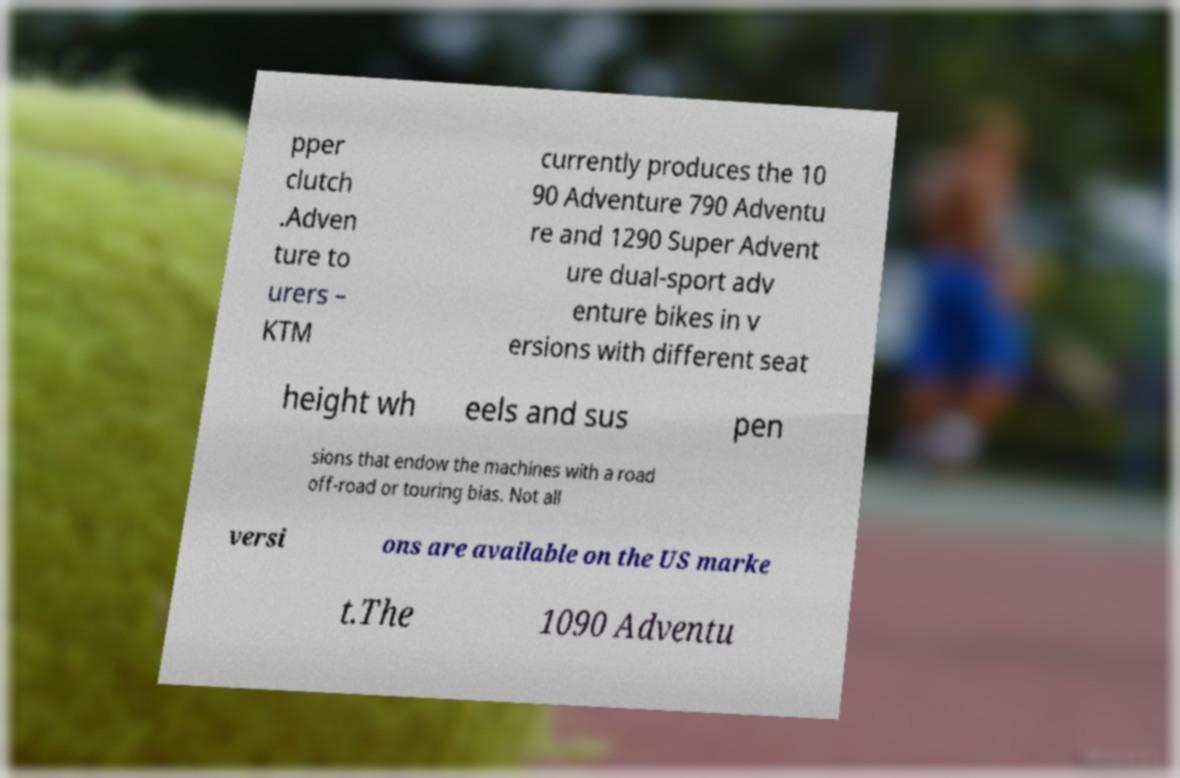Please read and relay the text visible in this image. What does it say? pper clutch .Adven ture to urers – KTM currently produces the 10 90 Adventure 790 Adventu re and 1290 Super Advent ure dual-sport adv enture bikes in v ersions with different seat height wh eels and sus pen sions that endow the machines with a road off-road or touring bias. Not all versi ons are available on the US marke t.The 1090 Adventu 